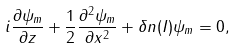Convert formula to latex. <formula><loc_0><loc_0><loc_500><loc_500>i \frac { \partial \psi _ { m } } { \partial z } + \frac { 1 } { 2 } \frac { \partial ^ { 2 } \psi _ { m } } { \partial x ^ { 2 } } + \delta n ( I ) \psi _ { m } = 0 ,</formula> 